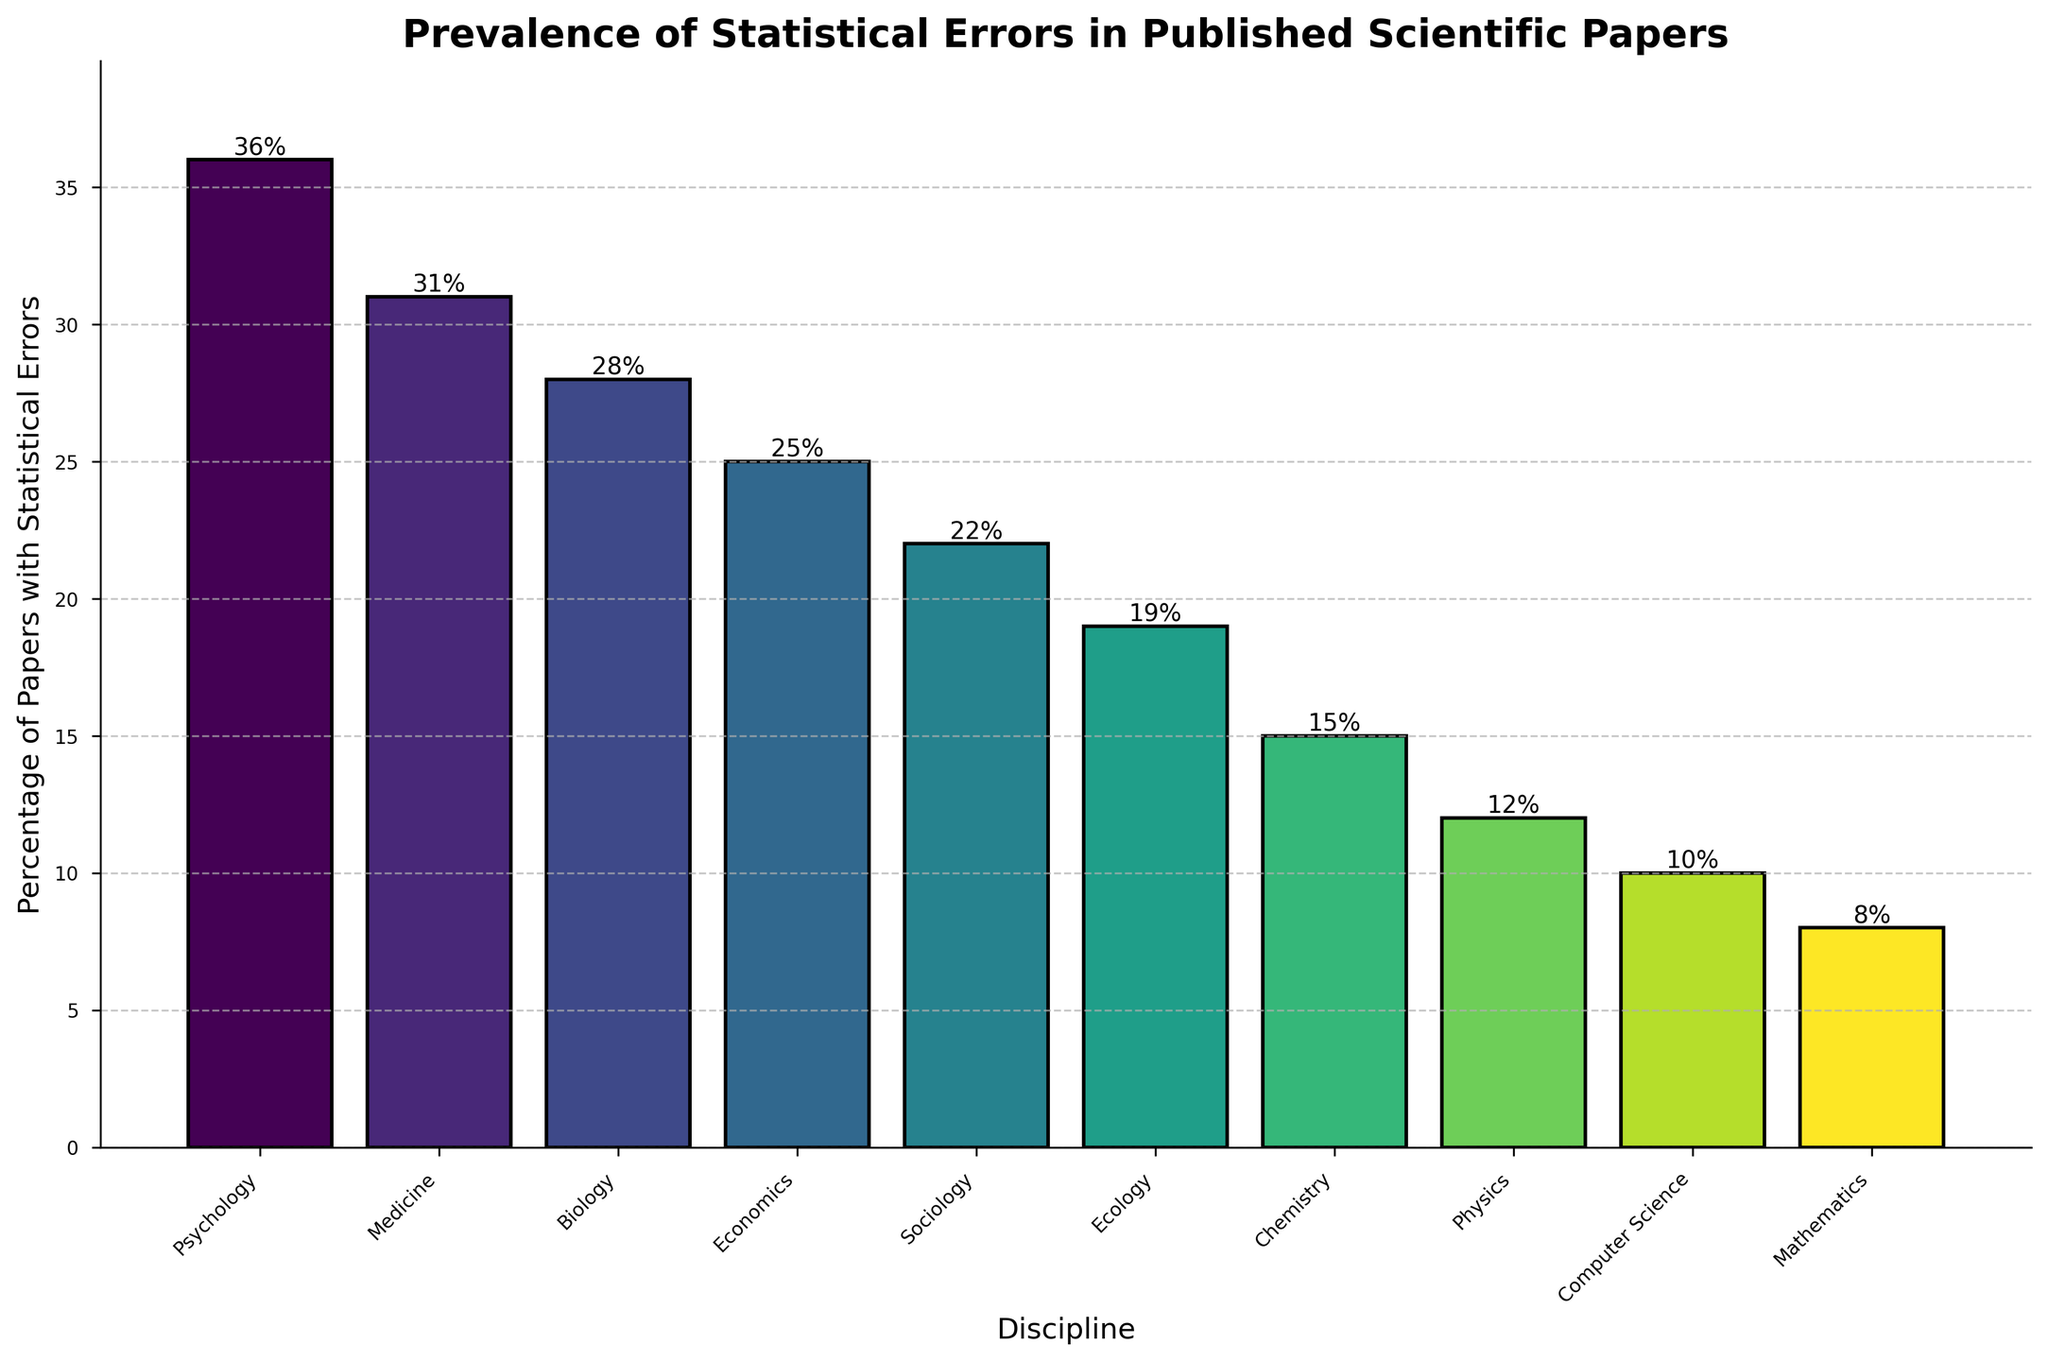What is the discipline with the highest percentage of papers with statistical errors? By inspecting the bar chart, the tallest bar corresponds to the discipline with the highest percentage. The label on that bar indicates it is "Psychology" with 36%.
Answer: Psychology Which discipline has fewer statistical errors, Chemistry or Physics? Compare the heights of the bars for Chemistry and Physics. Chemistry has a 15% error rate, and Physics has a 12% error rate, making Physics the one with fewer statistical errors.
Answer: Physics What is the percentage difference in statistical errors between Medicine and Biology? Subtract the percentage of statistical errors in Biology (28%) from that in Medicine (31%). The calculation is 31% - 28% = 3%.
Answer: 3% Which disciplines have a percentage of statistical errors lower than 20%? Identify the bars that fall below the 20% mark on the chart. These are Ecology, Chemistry, Physics, Computer Science, and Mathematics.
Answer: Ecology, Chemistry, Physics, Computer Science, Mathematics What is the average percentage of papers with statistical errors across all disciplines? Add the percentages for all disciplines (36 + 31 + 28 + 25 + 22 + 19 + 15 + 12 + 10 + 8) = 206. Then divide by the number of disciplines, which is 10. The average is 206 / 10 = 20.6%.
Answer: 20.6% Between which two consecutive disciplines is the largest drop in the percentage of statistical errors observed? By comparing the differences between each pair of adjacent disciplines starting from the highest to the lowest, the largest drop occurs between Chemistry (15%) and Physics (12%), which is a difference of 3%.
Answer: Chemistry and Physics By what percentage do statistical errors in Computer Science papers differ from those in Mathematics papers? Subtract the percentage of statistical errors in Mathematics (8%) from that in Computer Science (10%). The calculation is 10% - 8% = 2%.
Answer: 2% Considering the disciplines Sociology and Ecology, which one has a higher error rate and by how much? Compare the percentages for Sociology (22%) and Ecology (19%). Sociology has a higher error rate, and the difference is 22% - 19% = 3%.
Answer: Sociology, 3% How many disciplines fall under the range of 10% to 20% in statistical error rates? Count the bars that fall within the 10% to 20% range. These are Ecology (19%), Chemistry (15%), Physics (12%), and Computer Science (10%).
Answer: 4 Is the percentage of statistical errors in Medicine greater than, less than, or equal to that in Economics? Compare the percentages for Medicine (31%) and Economics (25%). Medicine has a greater percentage of statistical errors than Economics.
Answer: Greater than 